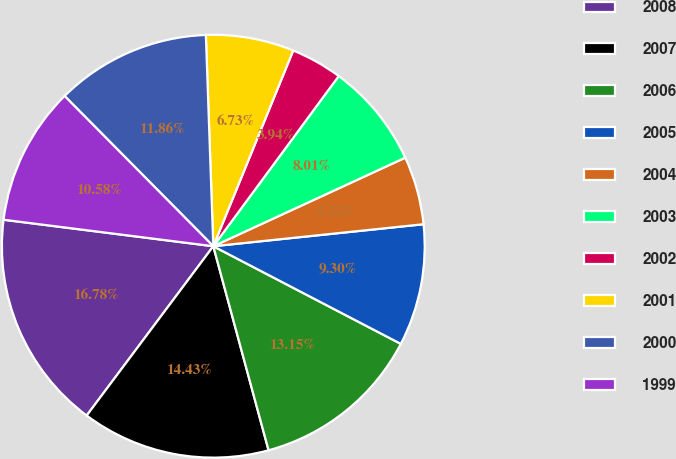Convert chart. <chart><loc_0><loc_0><loc_500><loc_500><pie_chart><fcel>2008<fcel>2007<fcel>2006<fcel>2005<fcel>2004<fcel>2003<fcel>2002<fcel>2001<fcel>2000<fcel>1999<nl><fcel>16.78%<fcel>14.43%<fcel>13.15%<fcel>9.3%<fcel>5.22%<fcel>8.01%<fcel>3.94%<fcel>6.73%<fcel>11.86%<fcel>10.58%<nl></chart> 